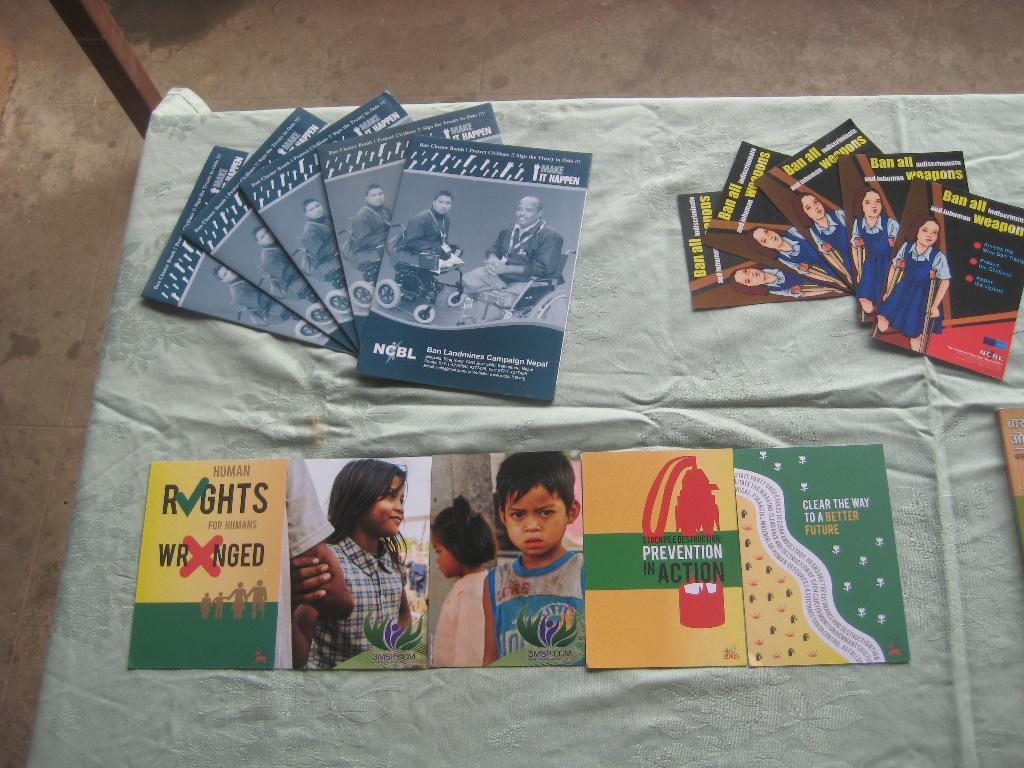What objects are on the table in the image? There are cards on the table. Can you describe the cards on the table? The cards are of different types. What type of breakfast is being served on the table in the image? There is no breakfast present in the image; it only features cards on the table. Can you see any icicles hanging from the cards in the image? There are no icicles present in the image; it only features cards on the table. 